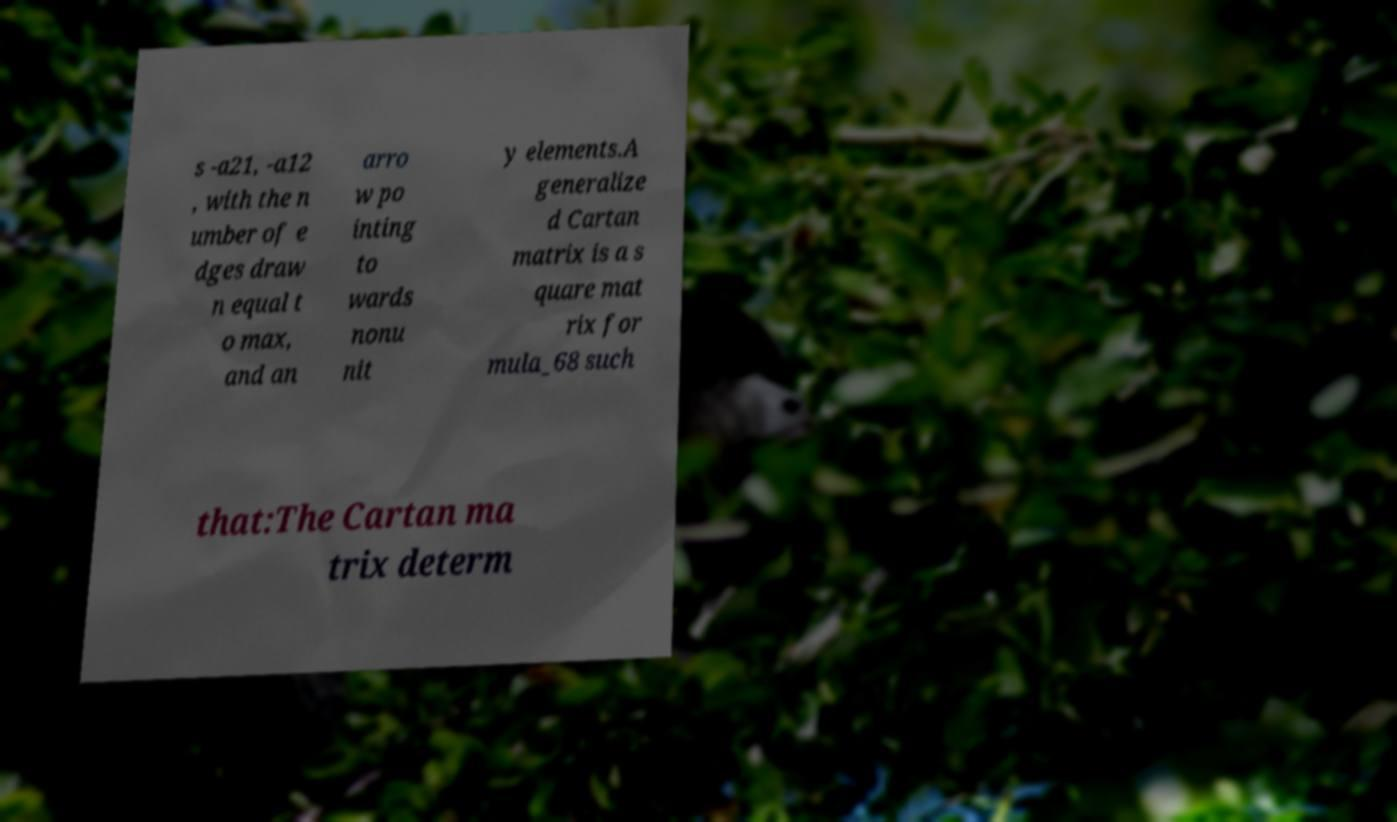Could you extract and type out the text from this image? s -a21, -a12 , with the n umber of e dges draw n equal t o max, and an arro w po inting to wards nonu nit y elements.A generalize d Cartan matrix is a s quare mat rix for mula_68 such that:The Cartan ma trix determ 